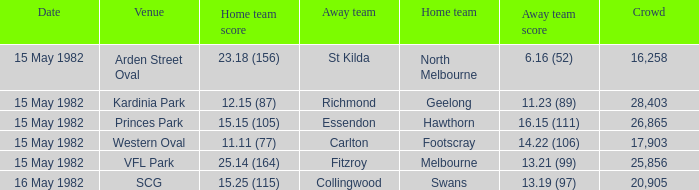What did the away team score when playing Footscray? 14.22 (106). 